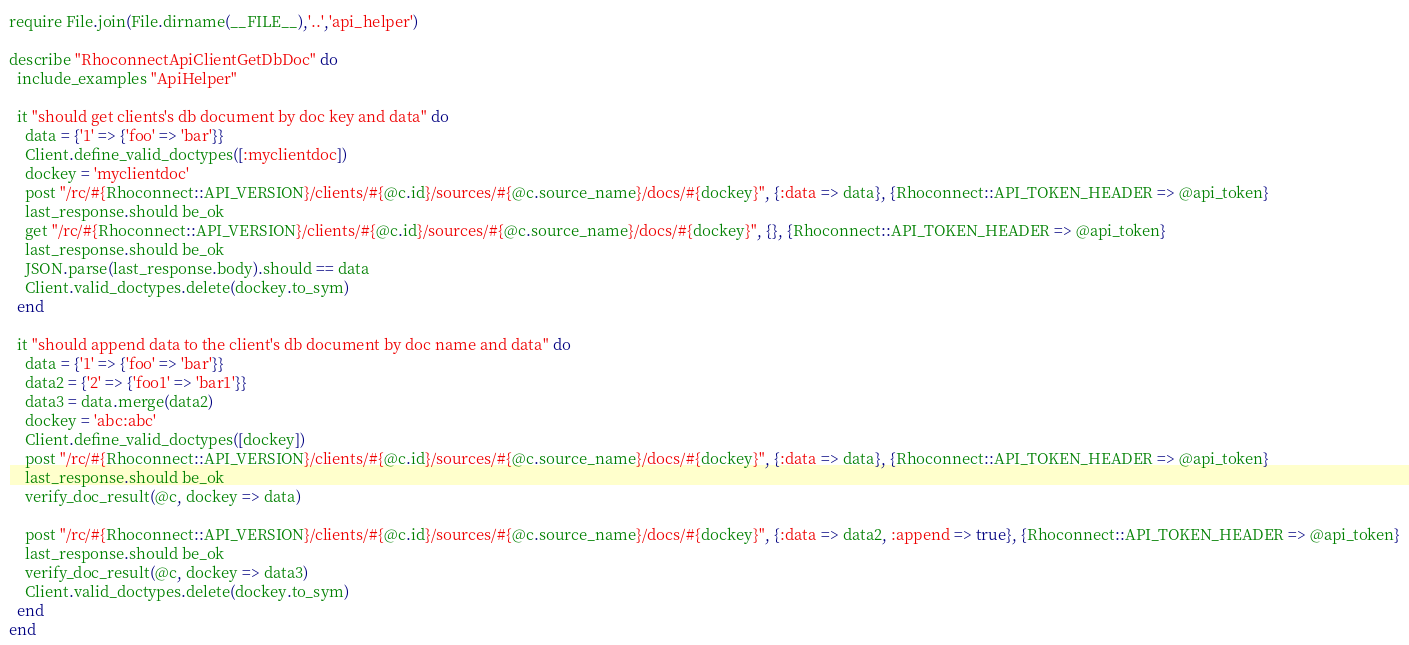<code> <loc_0><loc_0><loc_500><loc_500><_Ruby_>require File.join(File.dirname(__FILE__),'..','api_helper')

describe "RhoconnectApiClientGetDbDoc" do
  include_examples "ApiHelper"

  it "should get clients's db document by doc key and data" do
    data = {'1' => {'foo' => 'bar'}}
    Client.define_valid_doctypes([:myclientdoc])
    dockey = 'myclientdoc'
    post "/rc/#{Rhoconnect::API_VERSION}/clients/#{@c.id}/sources/#{@c.source_name}/docs/#{dockey}", {:data => data}, {Rhoconnect::API_TOKEN_HEADER => @api_token}
    last_response.should be_ok
    get "/rc/#{Rhoconnect::API_VERSION}/clients/#{@c.id}/sources/#{@c.source_name}/docs/#{dockey}", {}, {Rhoconnect::API_TOKEN_HEADER => @api_token}
    last_response.should be_ok
    JSON.parse(last_response.body).should == data
    Client.valid_doctypes.delete(dockey.to_sym)
  end

  it "should append data to the client's db document by doc name and data" do
    data = {'1' => {'foo' => 'bar'}}
    data2 = {'2' => {'foo1' => 'bar1'}}
    data3 = data.merge(data2)
    dockey = 'abc:abc'
    Client.define_valid_doctypes([dockey])
    post "/rc/#{Rhoconnect::API_VERSION}/clients/#{@c.id}/sources/#{@c.source_name}/docs/#{dockey}", {:data => data}, {Rhoconnect::API_TOKEN_HEADER => @api_token}
    last_response.should be_ok
    verify_doc_result(@c, dockey => data)

    post "/rc/#{Rhoconnect::API_VERSION}/clients/#{@c.id}/sources/#{@c.source_name}/docs/#{dockey}", {:data => data2, :append => true}, {Rhoconnect::API_TOKEN_HEADER => @api_token}
    last_response.should be_ok
    verify_doc_result(@c, dockey => data3)
    Client.valid_doctypes.delete(dockey.to_sym)
  end
end</code> 